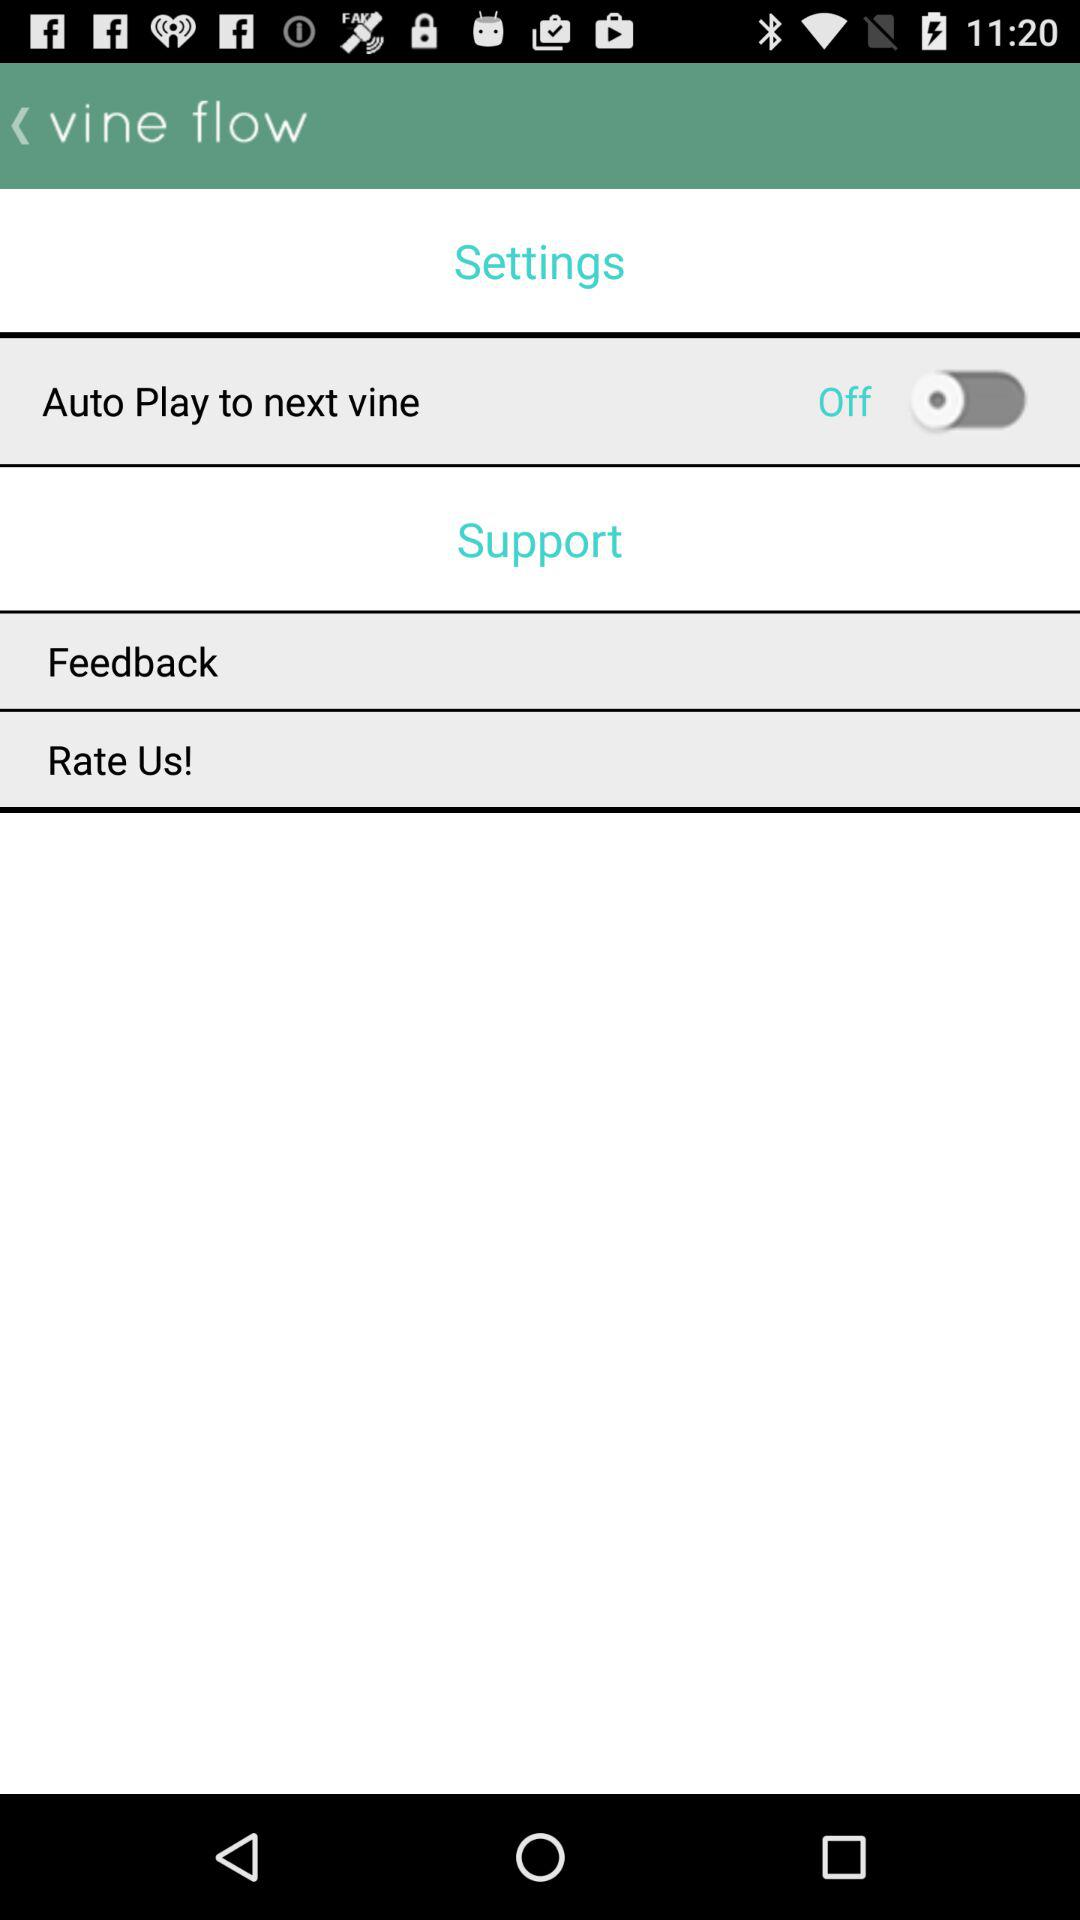What is the name of the application? The name of the application is "vine flow". 